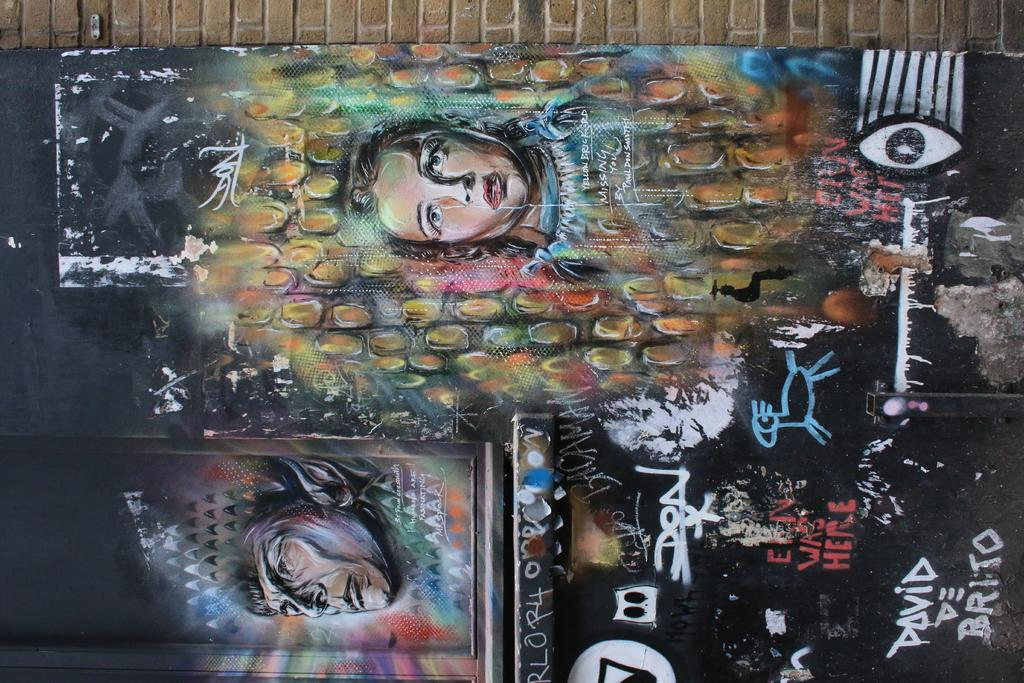What is the main object featured in the image? There is a painted board in the image. What else can be seen in the image besides the painted board? There is a brick wall in the image. What type of comb is used to style the painted board in the image? There is no comb present in the image, as it features a painted board and a brick wall. 